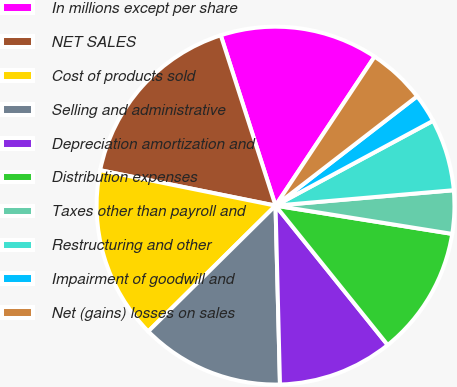Convert chart. <chart><loc_0><loc_0><loc_500><loc_500><pie_chart><fcel>In millions except per share<fcel>NET SALES<fcel>Cost of products sold<fcel>Selling and administrative<fcel>Depreciation amortization and<fcel>Distribution expenses<fcel>Taxes other than payroll and<fcel>Restructuring and other<fcel>Impairment of goodwill and<fcel>Net (gains) losses on sales<nl><fcel>14.29%<fcel>16.88%<fcel>15.58%<fcel>12.99%<fcel>10.39%<fcel>11.69%<fcel>3.9%<fcel>6.49%<fcel>2.6%<fcel>5.2%<nl></chart> 